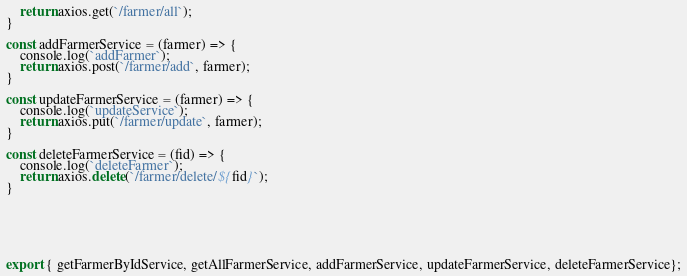Convert code to text. <code><loc_0><loc_0><loc_500><loc_500><_JavaScript_>    return axios.get(`/farmer/all`);
}

const addFarmerService = (farmer) => {
    console.log(`addFarmer`);
    return axios.post(`/farmer/add`, farmer);
}

const updateFarmerService = (farmer) => {
    console.log(`updateService`);
    return axios.put(`/farmer/update`, farmer);
}

const deleteFarmerService = (fid) => {
    console.log(`deleteFarmer`);
    return axios.delete(`/farmer/delete/${fid}`);
}






export { getFarmerByIdService, getAllFarmerService, addFarmerService, updateFarmerService, deleteFarmerService};</code> 